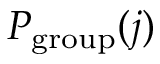Convert formula to latex. <formula><loc_0><loc_0><loc_500><loc_500>P _ { g r o u p } ( j )</formula> 